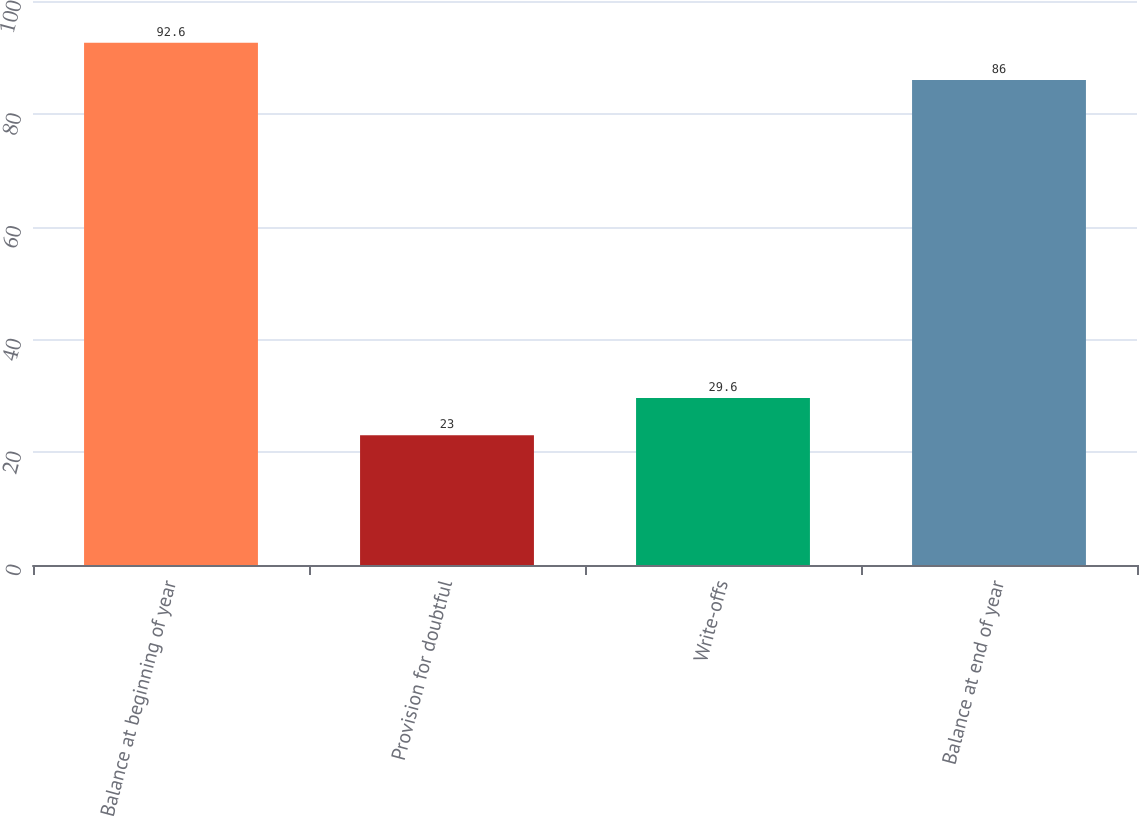<chart> <loc_0><loc_0><loc_500><loc_500><bar_chart><fcel>Balance at beginning of year<fcel>Provision for doubtful<fcel>Write-offs<fcel>Balance at end of year<nl><fcel>92.6<fcel>23<fcel>29.6<fcel>86<nl></chart> 